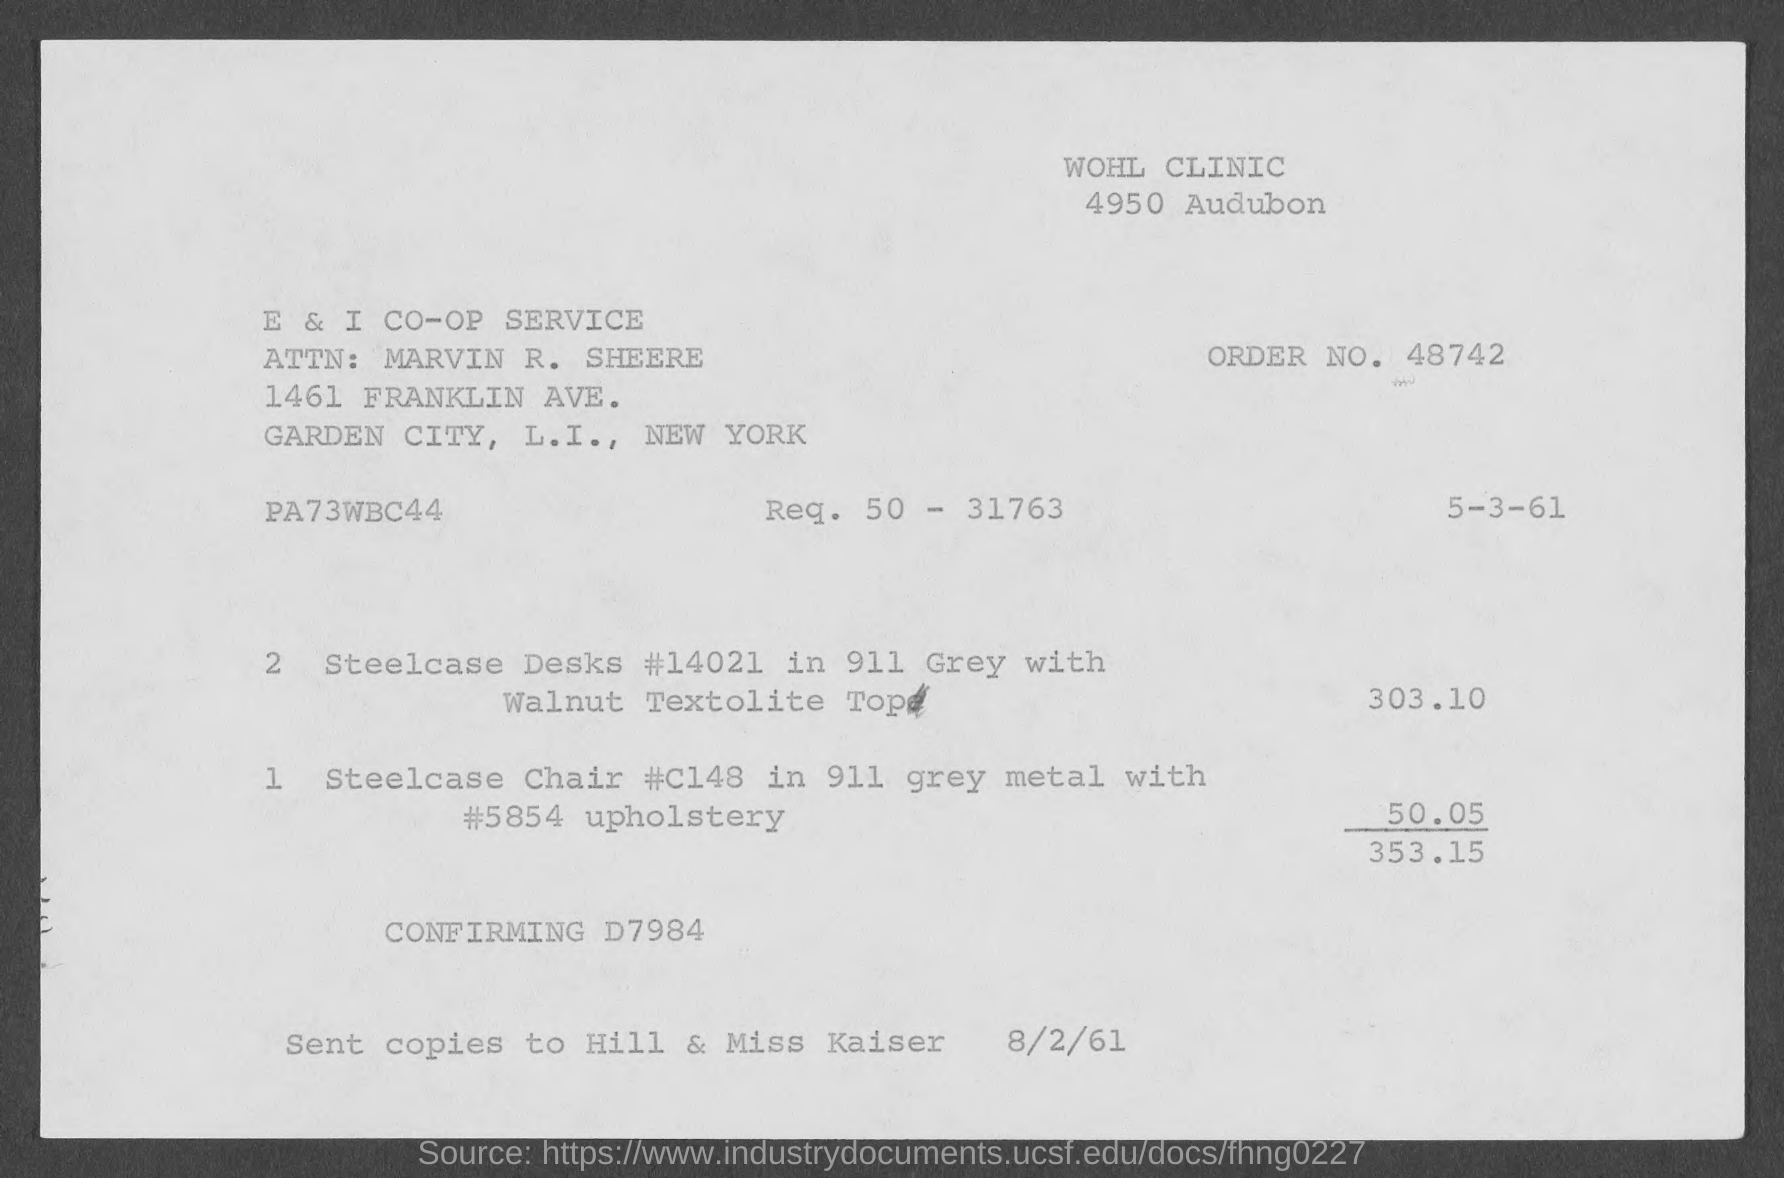Point out several critical features in this image. The total amount of the bill is 353.15. The order number is 48742... The price of the Steelcase desks is $303.10. The price of the Steelcase Chair is $50.05. 